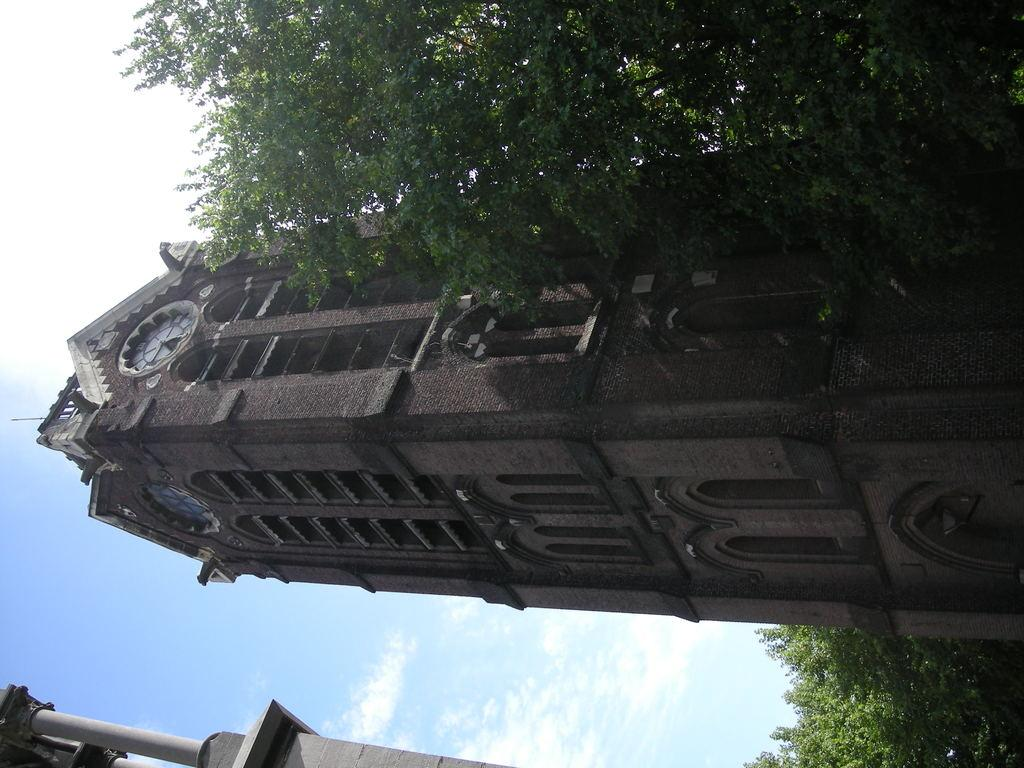What can be seen in the sky in the image? The sky is visible in the image, and there are clouds present. What type of structure is in the image? There is a building in the image. What feature is on the building? There is a clock on the building. What architectural element can be seen in the image? There is a pillar in the image. What type of vegetation is present in the image? There are trees in the image. What type of knowledge is being shared around the fire in the image? There is no fire present in the image, so knowledge sharing around a fire cannot be observed. 